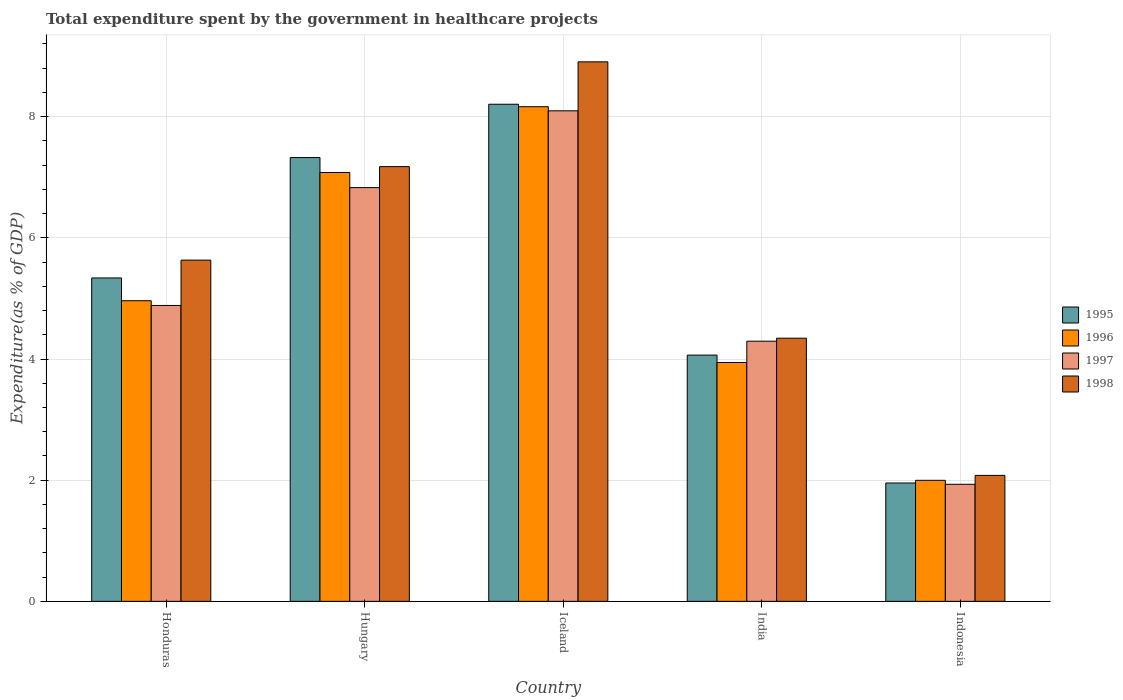How many groups of bars are there?
Provide a short and direct response. 5. Are the number of bars per tick equal to the number of legend labels?
Provide a short and direct response. Yes. Are the number of bars on each tick of the X-axis equal?
Ensure brevity in your answer.  Yes. How many bars are there on the 3rd tick from the right?
Provide a succinct answer. 4. What is the label of the 1st group of bars from the left?
Your answer should be very brief. Honduras. What is the total expenditure spent by the government in healthcare projects in 1998 in India?
Ensure brevity in your answer.  4.34. Across all countries, what is the maximum total expenditure spent by the government in healthcare projects in 1996?
Offer a terse response. 8.16. Across all countries, what is the minimum total expenditure spent by the government in healthcare projects in 1996?
Ensure brevity in your answer.  2. In which country was the total expenditure spent by the government in healthcare projects in 1997 maximum?
Your response must be concise. Iceland. In which country was the total expenditure spent by the government in healthcare projects in 1998 minimum?
Provide a short and direct response. Indonesia. What is the total total expenditure spent by the government in healthcare projects in 1998 in the graph?
Ensure brevity in your answer.  28.14. What is the difference between the total expenditure spent by the government in healthcare projects in 1996 in Hungary and that in Iceland?
Offer a very short reply. -1.09. What is the difference between the total expenditure spent by the government in healthcare projects in 1995 in Indonesia and the total expenditure spent by the government in healthcare projects in 1996 in Hungary?
Offer a very short reply. -5.12. What is the average total expenditure spent by the government in healthcare projects in 1996 per country?
Offer a very short reply. 5.23. What is the difference between the total expenditure spent by the government in healthcare projects of/in 1997 and total expenditure spent by the government in healthcare projects of/in 1995 in Indonesia?
Offer a terse response. -0.02. What is the ratio of the total expenditure spent by the government in healthcare projects in 1998 in Iceland to that in Indonesia?
Your answer should be compact. 4.28. Is the total expenditure spent by the government in healthcare projects in 1996 in India less than that in Indonesia?
Provide a succinct answer. No. What is the difference between the highest and the second highest total expenditure spent by the government in healthcare projects in 1997?
Your answer should be very brief. 3.21. What is the difference between the highest and the lowest total expenditure spent by the government in healthcare projects in 1996?
Your response must be concise. 6.17. What does the 4th bar from the left in India represents?
Your answer should be compact. 1998. What does the 4th bar from the right in Honduras represents?
Your answer should be compact. 1995. How many bars are there?
Provide a succinct answer. 20. How many countries are there in the graph?
Your response must be concise. 5. Does the graph contain any zero values?
Your response must be concise. No. What is the title of the graph?
Make the answer very short. Total expenditure spent by the government in healthcare projects. What is the label or title of the Y-axis?
Offer a very short reply. Expenditure(as % of GDP). What is the Expenditure(as % of GDP) in 1995 in Honduras?
Provide a succinct answer. 5.34. What is the Expenditure(as % of GDP) of 1996 in Honduras?
Make the answer very short. 4.96. What is the Expenditure(as % of GDP) of 1997 in Honduras?
Keep it short and to the point. 4.88. What is the Expenditure(as % of GDP) of 1998 in Honduras?
Give a very brief answer. 5.63. What is the Expenditure(as % of GDP) of 1995 in Hungary?
Your response must be concise. 7.33. What is the Expenditure(as % of GDP) in 1996 in Hungary?
Make the answer very short. 7.08. What is the Expenditure(as % of GDP) of 1997 in Hungary?
Your answer should be compact. 6.83. What is the Expenditure(as % of GDP) of 1998 in Hungary?
Your response must be concise. 7.18. What is the Expenditure(as % of GDP) in 1995 in Iceland?
Your answer should be compact. 8.21. What is the Expenditure(as % of GDP) of 1996 in Iceland?
Provide a succinct answer. 8.16. What is the Expenditure(as % of GDP) of 1997 in Iceland?
Provide a short and direct response. 8.1. What is the Expenditure(as % of GDP) of 1998 in Iceland?
Your answer should be compact. 8.91. What is the Expenditure(as % of GDP) in 1995 in India?
Your answer should be very brief. 4.06. What is the Expenditure(as % of GDP) of 1996 in India?
Offer a terse response. 3.94. What is the Expenditure(as % of GDP) in 1997 in India?
Your answer should be very brief. 4.29. What is the Expenditure(as % of GDP) of 1998 in India?
Give a very brief answer. 4.34. What is the Expenditure(as % of GDP) in 1995 in Indonesia?
Provide a succinct answer. 1.95. What is the Expenditure(as % of GDP) of 1996 in Indonesia?
Keep it short and to the point. 2. What is the Expenditure(as % of GDP) of 1997 in Indonesia?
Ensure brevity in your answer.  1.93. What is the Expenditure(as % of GDP) of 1998 in Indonesia?
Ensure brevity in your answer.  2.08. Across all countries, what is the maximum Expenditure(as % of GDP) in 1995?
Your answer should be very brief. 8.21. Across all countries, what is the maximum Expenditure(as % of GDP) of 1996?
Your response must be concise. 8.16. Across all countries, what is the maximum Expenditure(as % of GDP) of 1997?
Provide a succinct answer. 8.1. Across all countries, what is the maximum Expenditure(as % of GDP) in 1998?
Your answer should be compact. 8.91. Across all countries, what is the minimum Expenditure(as % of GDP) of 1995?
Offer a terse response. 1.95. Across all countries, what is the minimum Expenditure(as % of GDP) of 1996?
Your answer should be very brief. 2. Across all countries, what is the minimum Expenditure(as % of GDP) in 1997?
Offer a terse response. 1.93. Across all countries, what is the minimum Expenditure(as % of GDP) of 1998?
Keep it short and to the point. 2.08. What is the total Expenditure(as % of GDP) of 1995 in the graph?
Your answer should be compact. 26.89. What is the total Expenditure(as % of GDP) in 1996 in the graph?
Your answer should be very brief. 26.15. What is the total Expenditure(as % of GDP) of 1997 in the graph?
Your answer should be compact. 26.04. What is the total Expenditure(as % of GDP) of 1998 in the graph?
Give a very brief answer. 28.14. What is the difference between the Expenditure(as % of GDP) in 1995 in Honduras and that in Hungary?
Give a very brief answer. -1.99. What is the difference between the Expenditure(as % of GDP) in 1996 in Honduras and that in Hungary?
Your answer should be compact. -2.12. What is the difference between the Expenditure(as % of GDP) in 1997 in Honduras and that in Hungary?
Provide a short and direct response. -1.95. What is the difference between the Expenditure(as % of GDP) in 1998 in Honduras and that in Hungary?
Your response must be concise. -1.54. What is the difference between the Expenditure(as % of GDP) of 1995 in Honduras and that in Iceland?
Give a very brief answer. -2.87. What is the difference between the Expenditure(as % of GDP) of 1996 in Honduras and that in Iceland?
Provide a short and direct response. -3.2. What is the difference between the Expenditure(as % of GDP) of 1997 in Honduras and that in Iceland?
Your answer should be very brief. -3.21. What is the difference between the Expenditure(as % of GDP) of 1998 in Honduras and that in Iceland?
Your answer should be compact. -3.27. What is the difference between the Expenditure(as % of GDP) of 1995 in Honduras and that in India?
Give a very brief answer. 1.27. What is the difference between the Expenditure(as % of GDP) of 1996 in Honduras and that in India?
Give a very brief answer. 1.02. What is the difference between the Expenditure(as % of GDP) of 1997 in Honduras and that in India?
Give a very brief answer. 0.59. What is the difference between the Expenditure(as % of GDP) in 1998 in Honduras and that in India?
Provide a succinct answer. 1.29. What is the difference between the Expenditure(as % of GDP) in 1995 in Honduras and that in Indonesia?
Ensure brevity in your answer.  3.38. What is the difference between the Expenditure(as % of GDP) in 1996 in Honduras and that in Indonesia?
Make the answer very short. 2.96. What is the difference between the Expenditure(as % of GDP) of 1997 in Honduras and that in Indonesia?
Your answer should be very brief. 2.95. What is the difference between the Expenditure(as % of GDP) in 1998 in Honduras and that in Indonesia?
Your answer should be compact. 3.55. What is the difference between the Expenditure(as % of GDP) of 1995 in Hungary and that in Iceland?
Your answer should be very brief. -0.88. What is the difference between the Expenditure(as % of GDP) in 1996 in Hungary and that in Iceland?
Your answer should be very brief. -1.09. What is the difference between the Expenditure(as % of GDP) of 1997 in Hungary and that in Iceland?
Give a very brief answer. -1.27. What is the difference between the Expenditure(as % of GDP) of 1998 in Hungary and that in Iceland?
Your response must be concise. -1.73. What is the difference between the Expenditure(as % of GDP) of 1995 in Hungary and that in India?
Give a very brief answer. 3.26. What is the difference between the Expenditure(as % of GDP) in 1996 in Hungary and that in India?
Your answer should be very brief. 3.14. What is the difference between the Expenditure(as % of GDP) in 1997 in Hungary and that in India?
Your response must be concise. 2.54. What is the difference between the Expenditure(as % of GDP) of 1998 in Hungary and that in India?
Your response must be concise. 2.83. What is the difference between the Expenditure(as % of GDP) in 1995 in Hungary and that in Indonesia?
Provide a succinct answer. 5.37. What is the difference between the Expenditure(as % of GDP) in 1996 in Hungary and that in Indonesia?
Provide a short and direct response. 5.08. What is the difference between the Expenditure(as % of GDP) of 1997 in Hungary and that in Indonesia?
Offer a very short reply. 4.9. What is the difference between the Expenditure(as % of GDP) of 1998 in Hungary and that in Indonesia?
Provide a succinct answer. 5.1. What is the difference between the Expenditure(as % of GDP) of 1995 in Iceland and that in India?
Make the answer very short. 4.14. What is the difference between the Expenditure(as % of GDP) in 1996 in Iceland and that in India?
Give a very brief answer. 4.22. What is the difference between the Expenditure(as % of GDP) in 1997 in Iceland and that in India?
Offer a terse response. 3.8. What is the difference between the Expenditure(as % of GDP) of 1998 in Iceland and that in India?
Provide a succinct answer. 4.56. What is the difference between the Expenditure(as % of GDP) in 1995 in Iceland and that in Indonesia?
Provide a short and direct response. 6.25. What is the difference between the Expenditure(as % of GDP) in 1996 in Iceland and that in Indonesia?
Provide a short and direct response. 6.17. What is the difference between the Expenditure(as % of GDP) of 1997 in Iceland and that in Indonesia?
Keep it short and to the point. 6.16. What is the difference between the Expenditure(as % of GDP) of 1998 in Iceland and that in Indonesia?
Your response must be concise. 6.83. What is the difference between the Expenditure(as % of GDP) of 1995 in India and that in Indonesia?
Make the answer very short. 2.11. What is the difference between the Expenditure(as % of GDP) in 1996 in India and that in Indonesia?
Your answer should be very brief. 1.94. What is the difference between the Expenditure(as % of GDP) of 1997 in India and that in Indonesia?
Ensure brevity in your answer.  2.36. What is the difference between the Expenditure(as % of GDP) of 1998 in India and that in Indonesia?
Provide a short and direct response. 2.26. What is the difference between the Expenditure(as % of GDP) in 1995 in Honduras and the Expenditure(as % of GDP) in 1996 in Hungary?
Your response must be concise. -1.74. What is the difference between the Expenditure(as % of GDP) in 1995 in Honduras and the Expenditure(as % of GDP) in 1997 in Hungary?
Provide a short and direct response. -1.49. What is the difference between the Expenditure(as % of GDP) in 1995 in Honduras and the Expenditure(as % of GDP) in 1998 in Hungary?
Provide a short and direct response. -1.84. What is the difference between the Expenditure(as % of GDP) in 1996 in Honduras and the Expenditure(as % of GDP) in 1997 in Hungary?
Make the answer very short. -1.87. What is the difference between the Expenditure(as % of GDP) of 1996 in Honduras and the Expenditure(as % of GDP) of 1998 in Hungary?
Offer a very short reply. -2.21. What is the difference between the Expenditure(as % of GDP) in 1997 in Honduras and the Expenditure(as % of GDP) in 1998 in Hungary?
Offer a terse response. -2.29. What is the difference between the Expenditure(as % of GDP) in 1995 in Honduras and the Expenditure(as % of GDP) in 1996 in Iceland?
Make the answer very short. -2.83. What is the difference between the Expenditure(as % of GDP) of 1995 in Honduras and the Expenditure(as % of GDP) of 1997 in Iceland?
Your response must be concise. -2.76. What is the difference between the Expenditure(as % of GDP) of 1995 in Honduras and the Expenditure(as % of GDP) of 1998 in Iceland?
Your answer should be compact. -3.57. What is the difference between the Expenditure(as % of GDP) in 1996 in Honduras and the Expenditure(as % of GDP) in 1997 in Iceland?
Provide a succinct answer. -3.13. What is the difference between the Expenditure(as % of GDP) in 1996 in Honduras and the Expenditure(as % of GDP) in 1998 in Iceland?
Your response must be concise. -3.94. What is the difference between the Expenditure(as % of GDP) in 1997 in Honduras and the Expenditure(as % of GDP) in 1998 in Iceland?
Provide a succinct answer. -4.02. What is the difference between the Expenditure(as % of GDP) in 1995 in Honduras and the Expenditure(as % of GDP) in 1996 in India?
Your answer should be compact. 1.4. What is the difference between the Expenditure(as % of GDP) of 1995 in Honduras and the Expenditure(as % of GDP) of 1997 in India?
Provide a short and direct response. 1.04. What is the difference between the Expenditure(as % of GDP) in 1996 in Honduras and the Expenditure(as % of GDP) in 1997 in India?
Give a very brief answer. 0.67. What is the difference between the Expenditure(as % of GDP) in 1996 in Honduras and the Expenditure(as % of GDP) in 1998 in India?
Keep it short and to the point. 0.62. What is the difference between the Expenditure(as % of GDP) in 1997 in Honduras and the Expenditure(as % of GDP) in 1998 in India?
Your answer should be compact. 0.54. What is the difference between the Expenditure(as % of GDP) in 1995 in Honduras and the Expenditure(as % of GDP) in 1996 in Indonesia?
Ensure brevity in your answer.  3.34. What is the difference between the Expenditure(as % of GDP) of 1995 in Honduras and the Expenditure(as % of GDP) of 1997 in Indonesia?
Provide a succinct answer. 3.41. What is the difference between the Expenditure(as % of GDP) in 1995 in Honduras and the Expenditure(as % of GDP) in 1998 in Indonesia?
Provide a succinct answer. 3.26. What is the difference between the Expenditure(as % of GDP) of 1996 in Honduras and the Expenditure(as % of GDP) of 1997 in Indonesia?
Keep it short and to the point. 3.03. What is the difference between the Expenditure(as % of GDP) of 1996 in Honduras and the Expenditure(as % of GDP) of 1998 in Indonesia?
Ensure brevity in your answer.  2.88. What is the difference between the Expenditure(as % of GDP) in 1997 in Honduras and the Expenditure(as % of GDP) in 1998 in Indonesia?
Your response must be concise. 2.8. What is the difference between the Expenditure(as % of GDP) in 1995 in Hungary and the Expenditure(as % of GDP) in 1996 in Iceland?
Offer a terse response. -0.84. What is the difference between the Expenditure(as % of GDP) in 1995 in Hungary and the Expenditure(as % of GDP) in 1997 in Iceland?
Your answer should be very brief. -0.77. What is the difference between the Expenditure(as % of GDP) of 1995 in Hungary and the Expenditure(as % of GDP) of 1998 in Iceland?
Offer a terse response. -1.58. What is the difference between the Expenditure(as % of GDP) of 1996 in Hungary and the Expenditure(as % of GDP) of 1997 in Iceland?
Offer a very short reply. -1.02. What is the difference between the Expenditure(as % of GDP) in 1996 in Hungary and the Expenditure(as % of GDP) in 1998 in Iceland?
Offer a terse response. -1.83. What is the difference between the Expenditure(as % of GDP) in 1997 in Hungary and the Expenditure(as % of GDP) in 1998 in Iceland?
Give a very brief answer. -2.08. What is the difference between the Expenditure(as % of GDP) of 1995 in Hungary and the Expenditure(as % of GDP) of 1996 in India?
Your answer should be very brief. 3.38. What is the difference between the Expenditure(as % of GDP) in 1995 in Hungary and the Expenditure(as % of GDP) in 1997 in India?
Provide a succinct answer. 3.03. What is the difference between the Expenditure(as % of GDP) in 1995 in Hungary and the Expenditure(as % of GDP) in 1998 in India?
Keep it short and to the point. 2.98. What is the difference between the Expenditure(as % of GDP) in 1996 in Hungary and the Expenditure(as % of GDP) in 1997 in India?
Your answer should be very brief. 2.78. What is the difference between the Expenditure(as % of GDP) in 1996 in Hungary and the Expenditure(as % of GDP) in 1998 in India?
Ensure brevity in your answer.  2.73. What is the difference between the Expenditure(as % of GDP) of 1997 in Hungary and the Expenditure(as % of GDP) of 1998 in India?
Your response must be concise. 2.49. What is the difference between the Expenditure(as % of GDP) of 1995 in Hungary and the Expenditure(as % of GDP) of 1996 in Indonesia?
Give a very brief answer. 5.33. What is the difference between the Expenditure(as % of GDP) in 1995 in Hungary and the Expenditure(as % of GDP) in 1997 in Indonesia?
Your answer should be very brief. 5.39. What is the difference between the Expenditure(as % of GDP) in 1995 in Hungary and the Expenditure(as % of GDP) in 1998 in Indonesia?
Give a very brief answer. 5.25. What is the difference between the Expenditure(as % of GDP) of 1996 in Hungary and the Expenditure(as % of GDP) of 1997 in Indonesia?
Your answer should be compact. 5.15. What is the difference between the Expenditure(as % of GDP) in 1996 in Hungary and the Expenditure(as % of GDP) in 1998 in Indonesia?
Ensure brevity in your answer.  5. What is the difference between the Expenditure(as % of GDP) in 1997 in Hungary and the Expenditure(as % of GDP) in 1998 in Indonesia?
Your answer should be very brief. 4.75. What is the difference between the Expenditure(as % of GDP) of 1995 in Iceland and the Expenditure(as % of GDP) of 1996 in India?
Provide a short and direct response. 4.26. What is the difference between the Expenditure(as % of GDP) in 1995 in Iceland and the Expenditure(as % of GDP) in 1997 in India?
Your answer should be compact. 3.91. What is the difference between the Expenditure(as % of GDP) of 1995 in Iceland and the Expenditure(as % of GDP) of 1998 in India?
Your response must be concise. 3.86. What is the difference between the Expenditure(as % of GDP) of 1996 in Iceland and the Expenditure(as % of GDP) of 1997 in India?
Your answer should be very brief. 3.87. What is the difference between the Expenditure(as % of GDP) of 1996 in Iceland and the Expenditure(as % of GDP) of 1998 in India?
Your answer should be compact. 3.82. What is the difference between the Expenditure(as % of GDP) in 1997 in Iceland and the Expenditure(as % of GDP) in 1998 in India?
Provide a succinct answer. 3.75. What is the difference between the Expenditure(as % of GDP) in 1995 in Iceland and the Expenditure(as % of GDP) in 1996 in Indonesia?
Your response must be concise. 6.21. What is the difference between the Expenditure(as % of GDP) in 1995 in Iceland and the Expenditure(as % of GDP) in 1997 in Indonesia?
Provide a short and direct response. 6.27. What is the difference between the Expenditure(as % of GDP) in 1995 in Iceland and the Expenditure(as % of GDP) in 1998 in Indonesia?
Give a very brief answer. 6.13. What is the difference between the Expenditure(as % of GDP) in 1996 in Iceland and the Expenditure(as % of GDP) in 1997 in Indonesia?
Provide a short and direct response. 6.23. What is the difference between the Expenditure(as % of GDP) in 1996 in Iceland and the Expenditure(as % of GDP) in 1998 in Indonesia?
Provide a succinct answer. 6.09. What is the difference between the Expenditure(as % of GDP) of 1997 in Iceland and the Expenditure(as % of GDP) of 1998 in Indonesia?
Ensure brevity in your answer.  6.02. What is the difference between the Expenditure(as % of GDP) in 1995 in India and the Expenditure(as % of GDP) in 1996 in Indonesia?
Provide a short and direct response. 2.07. What is the difference between the Expenditure(as % of GDP) in 1995 in India and the Expenditure(as % of GDP) in 1997 in Indonesia?
Keep it short and to the point. 2.13. What is the difference between the Expenditure(as % of GDP) in 1995 in India and the Expenditure(as % of GDP) in 1998 in Indonesia?
Keep it short and to the point. 1.99. What is the difference between the Expenditure(as % of GDP) of 1996 in India and the Expenditure(as % of GDP) of 1997 in Indonesia?
Provide a succinct answer. 2.01. What is the difference between the Expenditure(as % of GDP) in 1996 in India and the Expenditure(as % of GDP) in 1998 in Indonesia?
Keep it short and to the point. 1.86. What is the difference between the Expenditure(as % of GDP) of 1997 in India and the Expenditure(as % of GDP) of 1998 in Indonesia?
Your answer should be very brief. 2.21. What is the average Expenditure(as % of GDP) in 1995 per country?
Provide a short and direct response. 5.38. What is the average Expenditure(as % of GDP) in 1996 per country?
Provide a succinct answer. 5.23. What is the average Expenditure(as % of GDP) in 1997 per country?
Make the answer very short. 5.21. What is the average Expenditure(as % of GDP) of 1998 per country?
Ensure brevity in your answer.  5.63. What is the difference between the Expenditure(as % of GDP) in 1995 and Expenditure(as % of GDP) in 1996 in Honduras?
Offer a very short reply. 0.38. What is the difference between the Expenditure(as % of GDP) in 1995 and Expenditure(as % of GDP) in 1997 in Honduras?
Make the answer very short. 0.45. What is the difference between the Expenditure(as % of GDP) of 1995 and Expenditure(as % of GDP) of 1998 in Honduras?
Offer a very short reply. -0.29. What is the difference between the Expenditure(as % of GDP) in 1996 and Expenditure(as % of GDP) in 1997 in Honduras?
Give a very brief answer. 0.08. What is the difference between the Expenditure(as % of GDP) in 1996 and Expenditure(as % of GDP) in 1998 in Honduras?
Offer a very short reply. -0.67. What is the difference between the Expenditure(as % of GDP) in 1997 and Expenditure(as % of GDP) in 1998 in Honduras?
Provide a short and direct response. -0.75. What is the difference between the Expenditure(as % of GDP) of 1995 and Expenditure(as % of GDP) of 1996 in Hungary?
Make the answer very short. 0.25. What is the difference between the Expenditure(as % of GDP) in 1995 and Expenditure(as % of GDP) in 1997 in Hungary?
Offer a terse response. 0.5. What is the difference between the Expenditure(as % of GDP) of 1995 and Expenditure(as % of GDP) of 1998 in Hungary?
Your answer should be compact. 0.15. What is the difference between the Expenditure(as % of GDP) of 1996 and Expenditure(as % of GDP) of 1997 in Hungary?
Your response must be concise. 0.25. What is the difference between the Expenditure(as % of GDP) of 1996 and Expenditure(as % of GDP) of 1998 in Hungary?
Make the answer very short. -0.1. What is the difference between the Expenditure(as % of GDP) in 1997 and Expenditure(as % of GDP) in 1998 in Hungary?
Make the answer very short. -0.35. What is the difference between the Expenditure(as % of GDP) of 1995 and Expenditure(as % of GDP) of 1996 in Iceland?
Your answer should be very brief. 0.04. What is the difference between the Expenditure(as % of GDP) in 1995 and Expenditure(as % of GDP) in 1997 in Iceland?
Offer a terse response. 0.11. What is the difference between the Expenditure(as % of GDP) in 1995 and Expenditure(as % of GDP) in 1998 in Iceland?
Provide a succinct answer. -0.7. What is the difference between the Expenditure(as % of GDP) of 1996 and Expenditure(as % of GDP) of 1997 in Iceland?
Your response must be concise. 0.07. What is the difference between the Expenditure(as % of GDP) in 1996 and Expenditure(as % of GDP) in 1998 in Iceland?
Your answer should be very brief. -0.74. What is the difference between the Expenditure(as % of GDP) of 1997 and Expenditure(as % of GDP) of 1998 in Iceland?
Give a very brief answer. -0.81. What is the difference between the Expenditure(as % of GDP) in 1995 and Expenditure(as % of GDP) in 1996 in India?
Provide a short and direct response. 0.12. What is the difference between the Expenditure(as % of GDP) of 1995 and Expenditure(as % of GDP) of 1997 in India?
Provide a succinct answer. -0.23. What is the difference between the Expenditure(as % of GDP) of 1995 and Expenditure(as % of GDP) of 1998 in India?
Your response must be concise. -0.28. What is the difference between the Expenditure(as % of GDP) in 1996 and Expenditure(as % of GDP) in 1997 in India?
Make the answer very short. -0.35. What is the difference between the Expenditure(as % of GDP) of 1996 and Expenditure(as % of GDP) of 1998 in India?
Give a very brief answer. -0.4. What is the difference between the Expenditure(as % of GDP) in 1997 and Expenditure(as % of GDP) in 1998 in India?
Give a very brief answer. -0.05. What is the difference between the Expenditure(as % of GDP) of 1995 and Expenditure(as % of GDP) of 1996 in Indonesia?
Your response must be concise. -0.04. What is the difference between the Expenditure(as % of GDP) in 1995 and Expenditure(as % of GDP) in 1997 in Indonesia?
Offer a terse response. 0.02. What is the difference between the Expenditure(as % of GDP) of 1995 and Expenditure(as % of GDP) of 1998 in Indonesia?
Keep it short and to the point. -0.13. What is the difference between the Expenditure(as % of GDP) in 1996 and Expenditure(as % of GDP) in 1997 in Indonesia?
Offer a terse response. 0.07. What is the difference between the Expenditure(as % of GDP) in 1996 and Expenditure(as % of GDP) in 1998 in Indonesia?
Provide a short and direct response. -0.08. What is the difference between the Expenditure(as % of GDP) of 1997 and Expenditure(as % of GDP) of 1998 in Indonesia?
Provide a succinct answer. -0.15. What is the ratio of the Expenditure(as % of GDP) in 1995 in Honduras to that in Hungary?
Your response must be concise. 0.73. What is the ratio of the Expenditure(as % of GDP) of 1996 in Honduras to that in Hungary?
Make the answer very short. 0.7. What is the ratio of the Expenditure(as % of GDP) in 1997 in Honduras to that in Hungary?
Ensure brevity in your answer.  0.72. What is the ratio of the Expenditure(as % of GDP) of 1998 in Honduras to that in Hungary?
Give a very brief answer. 0.78. What is the ratio of the Expenditure(as % of GDP) of 1995 in Honduras to that in Iceland?
Offer a very short reply. 0.65. What is the ratio of the Expenditure(as % of GDP) in 1996 in Honduras to that in Iceland?
Make the answer very short. 0.61. What is the ratio of the Expenditure(as % of GDP) of 1997 in Honduras to that in Iceland?
Make the answer very short. 0.6. What is the ratio of the Expenditure(as % of GDP) in 1998 in Honduras to that in Iceland?
Your response must be concise. 0.63. What is the ratio of the Expenditure(as % of GDP) of 1995 in Honduras to that in India?
Your answer should be compact. 1.31. What is the ratio of the Expenditure(as % of GDP) in 1996 in Honduras to that in India?
Your response must be concise. 1.26. What is the ratio of the Expenditure(as % of GDP) in 1997 in Honduras to that in India?
Your response must be concise. 1.14. What is the ratio of the Expenditure(as % of GDP) of 1998 in Honduras to that in India?
Give a very brief answer. 1.3. What is the ratio of the Expenditure(as % of GDP) of 1995 in Honduras to that in Indonesia?
Offer a terse response. 2.73. What is the ratio of the Expenditure(as % of GDP) of 1996 in Honduras to that in Indonesia?
Your answer should be very brief. 2.48. What is the ratio of the Expenditure(as % of GDP) of 1997 in Honduras to that in Indonesia?
Ensure brevity in your answer.  2.53. What is the ratio of the Expenditure(as % of GDP) in 1998 in Honduras to that in Indonesia?
Offer a terse response. 2.71. What is the ratio of the Expenditure(as % of GDP) in 1995 in Hungary to that in Iceland?
Your answer should be compact. 0.89. What is the ratio of the Expenditure(as % of GDP) in 1996 in Hungary to that in Iceland?
Your answer should be very brief. 0.87. What is the ratio of the Expenditure(as % of GDP) in 1997 in Hungary to that in Iceland?
Provide a short and direct response. 0.84. What is the ratio of the Expenditure(as % of GDP) in 1998 in Hungary to that in Iceland?
Offer a terse response. 0.81. What is the ratio of the Expenditure(as % of GDP) of 1995 in Hungary to that in India?
Keep it short and to the point. 1.8. What is the ratio of the Expenditure(as % of GDP) in 1996 in Hungary to that in India?
Your response must be concise. 1.8. What is the ratio of the Expenditure(as % of GDP) in 1997 in Hungary to that in India?
Your answer should be compact. 1.59. What is the ratio of the Expenditure(as % of GDP) of 1998 in Hungary to that in India?
Make the answer very short. 1.65. What is the ratio of the Expenditure(as % of GDP) of 1995 in Hungary to that in Indonesia?
Make the answer very short. 3.75. What is the ratio of the Expenditure(as % of GDP) of 1996 in Hungary to that in Indonesia?
Your answer should be very brief. 3.54. What is the ratio of the Expenditure(as % of GDP) in 1997 in Hungary to that in Indonesia?
Make the answer very short. 3.53. What is the ratio of the Expenditure(as % of GDP) of 1998 in Hungary to that in Indonesia?
Give a very brief answer. 3.45. What is the ratio of the Expenditure(as % of GDP) in 1995 in Iceland to that in India?
Make the answer very short. 2.02. What is the ratio of the Expenditure(as % of GDP) in 1996 in Iceland to that in India?
Keep it short and to the point. 2.07. What is the ratio of the Expenditure(as % of GDP) of 1997 in Iceland to that in India?
Provide a short and direct response. 1.89. What is the ratio of the Expenditure(as % of GDP) of 1998 in Iceland to that in India?
Provide a succinct answer. 2.05. What is the ratio of the Expenditure(as % of GDP) of 1995 in Iceland to that in Indonesia?
Your answer should be compact. 4.2. What is the ratio of the Expenditure(as % of GDP) in 1996 in Iceland to that in Indonesia?
Your answer should be compact. 4.09. What is the ratio of the Expenditure(as % of GDP) in 1997 in Iceland to that in Indonesia?
Your response must be concise. 4.19. What is the ratio of the Expenditure(as % of GDP) of 1998 in Iceland to that in Indonesia?
Your answer should be very brief. 4.28. What is the ratio of the Expenditure(as % of GDP) of 1995 in India to that in Indonesia?
Offer a very short reply. 2.08. What is the ratio of the Expenditure(as % of GDP) of 1996 in India to that in Indonesia?
Ensure brevity in your answer.  1.97. What is the ratio of the Expenditure(as % of GDP) in 1997 in India to that in Indonesia?
Your answer should be compact. 2.22. What is the ratio of the Expenditure(as % of GDP) in 1998 in India to that in Indonesia?
Your response must be concise. 2.09. What is the difference between the highest and the second highest Expenditure(as % of GDP) in 1995?
Provide a short and direct response. 0.88. What is the difference between the highest and the second highest Expenditure(as % of GDP) in 1996?
Give a very brief answer. 1.09. What is the difference between the highest and the second highest Expenditure(as % of GDP) of 1997?
Keep it short and to the point. 1.27. What is the difference between the highest and the second highest Expenditure(as % of GDP) of 1998?
Your response must be concise. 1.73. What is the difference between the highest and the lowest Expenditure(as % of GDP) in 1995?
Your answer should be very brief. 6.25. What is the difference between the highest and the lowest Expenditure(as % of GDP) of 1996?
Offer a very short reply. 6.17. What is the difference between the highest and the lowest Expenditure(as % of GDP) in 1997?
Keep it short and to the point. 6.16. What is the difference between the highest and the lowest Expenditure(as % of GDP) in 1998?
Keep it short and to the point. 6.83. 